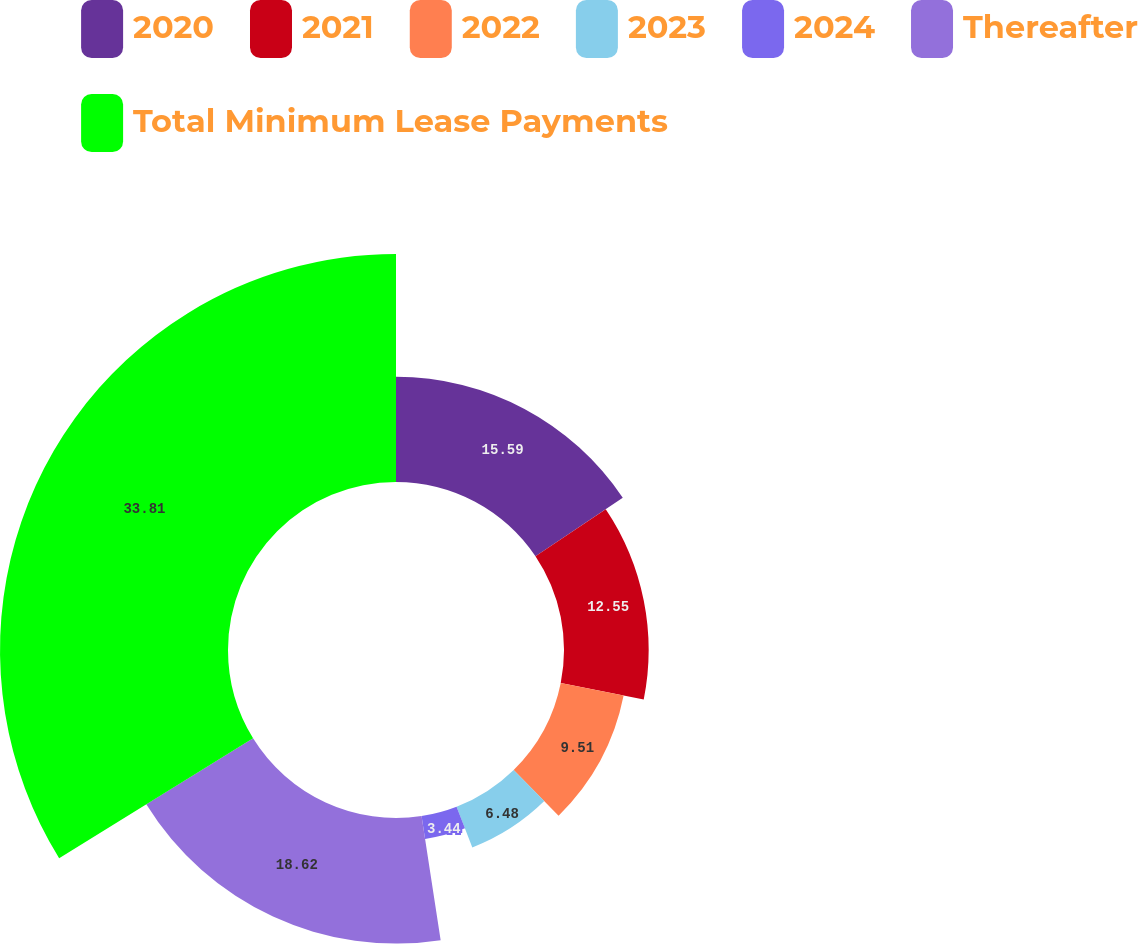<chart> <loc_0><loc_0><loc_500><loc_500><pie_chart><fcel>2020<fcel>2021<fcel>2022<fcel>2023<fcel>2024<fcel>Thereafter<fcel>Total Minimum Lease Payments<nl><fcel>15.59%<fcel>12.55%<fcel>9.51%<fcel>6.48%<fcel>3.44%<fcel>18.62%<fcel>33.81%<nl></chart> 